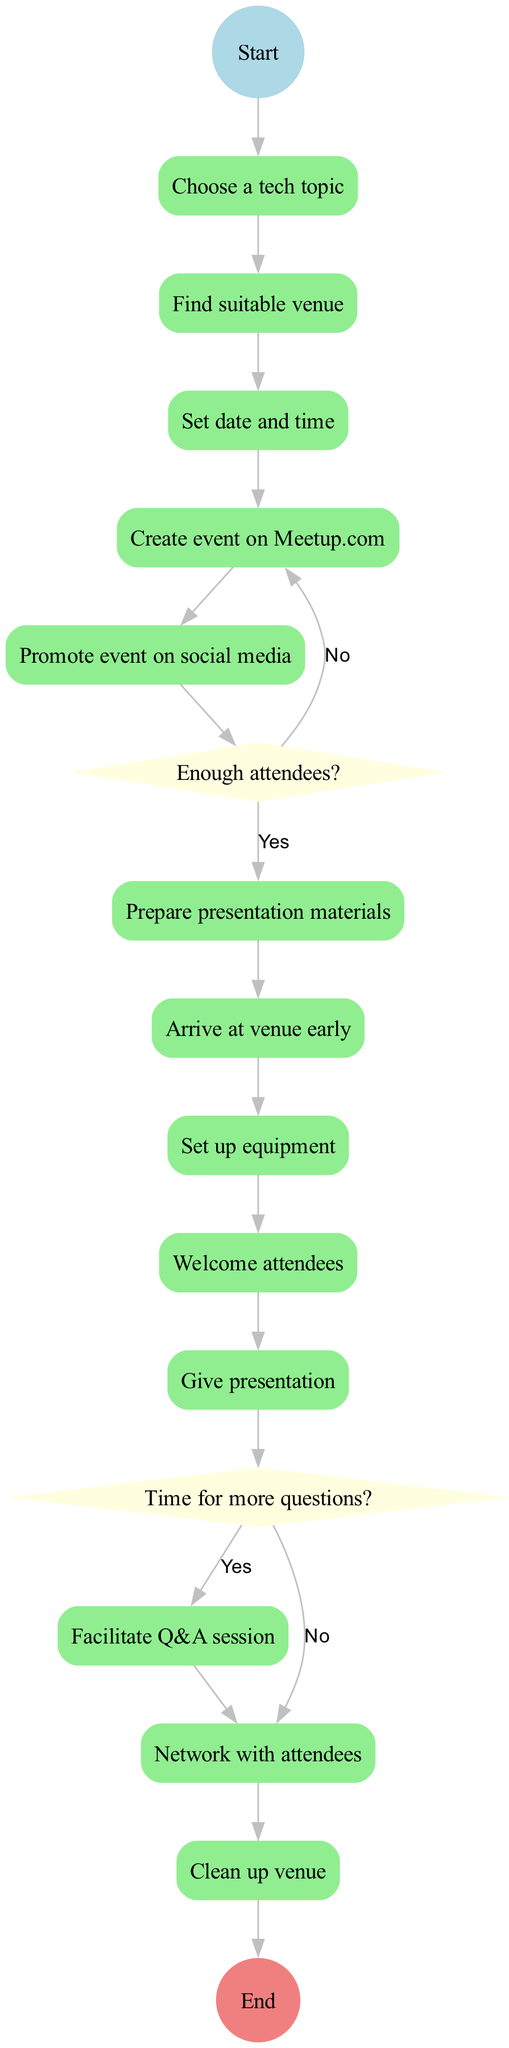What is the starting activity in the diagram? The starting activity, as indicated by the initial node labeled "Start," is the first step in the process of organizing and attending a local tech meetup event.
Answer: Choose a tech topic How many major activities are there in the diagram? The diagram lists all the activities in a sequence that includes each task involved. By counting the activities in the “activities” section, we find there are thirteen activities.
Answer: Thirteen What happens if there are not enough attendees? The diagram indicates that if the decision node "Enough attendees?" results in a "no," the flow directs back to "Reschedule event," indicating that the event cannot proceed.
Answer: Reschedule event What is the next step after "Give presentation" if there are time for more questions? Following "Give presentation," the diagram leads to the decision node "Time for more questions?" If the answer is "yes," the next step in the flow would be to "Continue Q&A session."
Answer: Continue Q&A session Which activity immediately follows "Promote event on social media"? In the diagram, after the activity "Promote event on social media," the flow directs to the decision point labeled "Enough attendees?" This indicates that promotion is directly linked to assessing the number of attendees.
Answer: Enough attendees? If the answer to "Time for more questions?" is "no," what is the next activity? According to the diagram, if the decision leads to "no" from the question "Time for more questions?", the next activity indicated in the flow is "End presentation," which terminates the presentation process.
Answer: End presentation How many decision nodes are present in the diagram? The diagram has two decision nodes that evaluate the situations regarding attendee numbers and question timing. By identifying these nodes, we can calculate that there are two points in the process where decisions need to be made.
Answer: Two What follows immediately after "Prepare presentation materials"? The diagram outlines the sequence of activities where "Prepare presentation materials" is followed by "Arrive at venue early," indicating the next step in the process for the organizer.
Answer: Arrive at venue early 